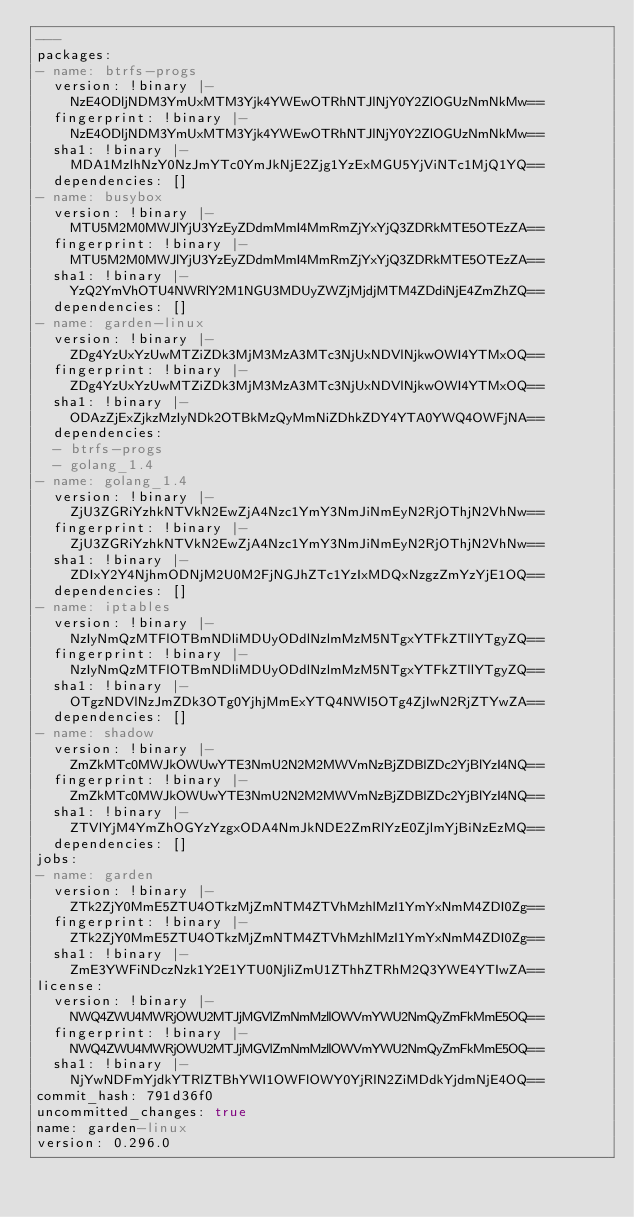<code> <loc_0><loc_0><loc_500><loc_500><_YAML_>---
packages:
- name: btrfs-progs
  version: !binary |-
    NzE4ODljNDM3YmUxMTM3Yjk4YWEwOTRhNTJlNjY0Y2ZlOGUzNmNkMw==
  fingerprint: !binary |-
    NzE4ODljNDM3YmUxMTM3Yjk4YWEwOTRhNTJlNjY0Y2ZlOGUzNmNkMw==
  sha1: !binary |-
    MDA1MzlhNzY0NzJmYTc0YmJkNjE2Zjg1YzExMGU5YjViNTc1MjQ1YQ==
  dependencies: []
- name: busybox
  version: !binary |-
    MTU5M2M0MWJlYjU3YzEyZDdmMmI4MmRmZjYxYjQ3ZDRkMTE5OTEzZA==
  fingerprint: !binary |-
    MTU5M2M0MWJlYjU3YzEyZDdmMmI4MmRmZjYxYjQ3ZDRkMTE5OTEzZA==
  sha1: !binary |-
    YzQ2YmVhOTU4NWRlY2M1NGU3MDUyZWZjMjdjMTM4ZDdiNjE4ZmZhZQ==
  dependencies: []
- name: garden-linux
  version: !binary |-
    ZDg4YzUxYzUwMTZiZDk3MjM3MzA3MTc3NjUxNDVlNjkwOWI4YTMxOQ==
  fingerprint: !binary |-
    ZDg4YzUxYzUwMTZiZDk3MjM3MzA3MTc3NjUxNDVlNjkwOWI4YTMxOQ==
  sha1: !binary |-
    ODAzZjExZjkzMzIyNDk2OTBkMzQyMmNiZDhkZDY4YTA0YWQ4OWFjNA==
  dependencies:
  - btrfs-progs
  - golang_1.4
- name: golang_1.4
  version: !binary |-
    ZjU3ZGRiYzhkNTVkN2EwZjA4Nzc1YmY3NmJiNmEyN2RjOThjN2VhNw==
  fingerprint: !binary |-
    ZjU3ZGRiYzhkNTVkN2EwZjA4Nzc1YmY3NmJiNmEyN2RjOThjN2VhNw==
  sha1: !binary |-
    ZDIxY2Y4NjhmODNjM2U0M2FjNGJhZTc1YzIxMDQxNzgzZmYzYjE1OQ==
  dependencies: []
- name: iptables
  version: !binary |-
    NzIyNmQzMTFlOTBmNDliMDUyODdlNzlmMzM5NTgxYTFkZTllYTgyZQ==
  fingerprint: !binary |-
    NzIyNmQzMTFlOTBmNDliMDUyODdlNzlmMzM5NTgxYTFkZTllYTgyZQ==
  sha1: !binary |-
    OTgzNDVlNzJmZDk3OTg0YjhjMmExYTQ4NWI5OTg4ZjIwN2RjZTYwZA==
  dependencies: []
- name: shadow
  version: !binary |-
    ZmZkMTc0MWJkOWUwYTE3NmU2N2M2MWVmNzBjZDBlZDc2YjBlYzI4NQ==
  fingerprint: !binary |-
    ZmZkMTc0MWJkOWUwYTE3NmU2N2M2MWVmNzBjZDBlZDc2YjBlYzI4NQ==
  sha1: !binary |-
    ZTVlYjM4YmZhOGYzYzgxODA4NmJkNDE2ZmRlYzE0ZjlmYjBiNzEzMQ==
  dependencies: []
jobs:
- name: garden
  version: !binary |-
    ZTk2ZjY0MmE5ZTU4OTkzMjZmNTM4ZTVhMzhlMzI1YmYxNmM4ZDI0Zg==
  fingerprint: !binary |-
    ZTk2ZjY0MmE5ZTU4OTkzMjZmNTM4ZTVhMzhlMzI1YmYxNmM4ZDI0Zg==
  sha1: !binary |-
    ZmE3YWFiNDczNzk1Y2E1YTU0NjliZmU1ZThhZTRhM2Q3YWE4YTIwZA==
license:
  version: !binary |-
    NWQ4ZWU4MWRjOWU2MTJjMGVlZmNmMzllOWVmYWU2NmQyZmFkMmE5OQ==
  fingerprint: !binary |-
    NWQ4ZWU4MWRjOWU2MTJjMGVlZmNmMzllOWVmYWU2NmQyZmFkMmE5OQ==
  sha1: !binary |-
    NjYwNDFmYjdkYTRlZTBhYWI1OWFlOWY0YjRlN2ZiMDdkYjdmNjE4OQ==
commit_hash: 791d36f0
uncommitted_changes: true
name: garden-linux
version: 0.296.0
</code> 